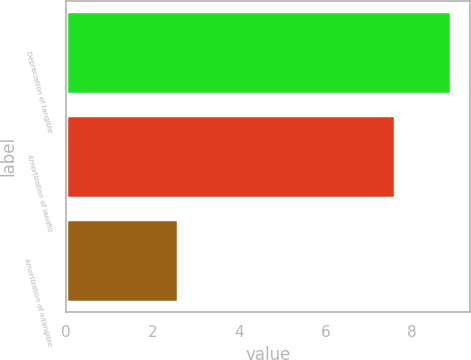<chart> <loc_0><loc_0><loc_500><loc_500><bar_chart><fcel>Depreciation of tangible<fcel>Amortization of landfill<fcel>Amortization of intangible<nl><fcel>8.9<fcel>7.6<fcel>2.6<nl></chart> 